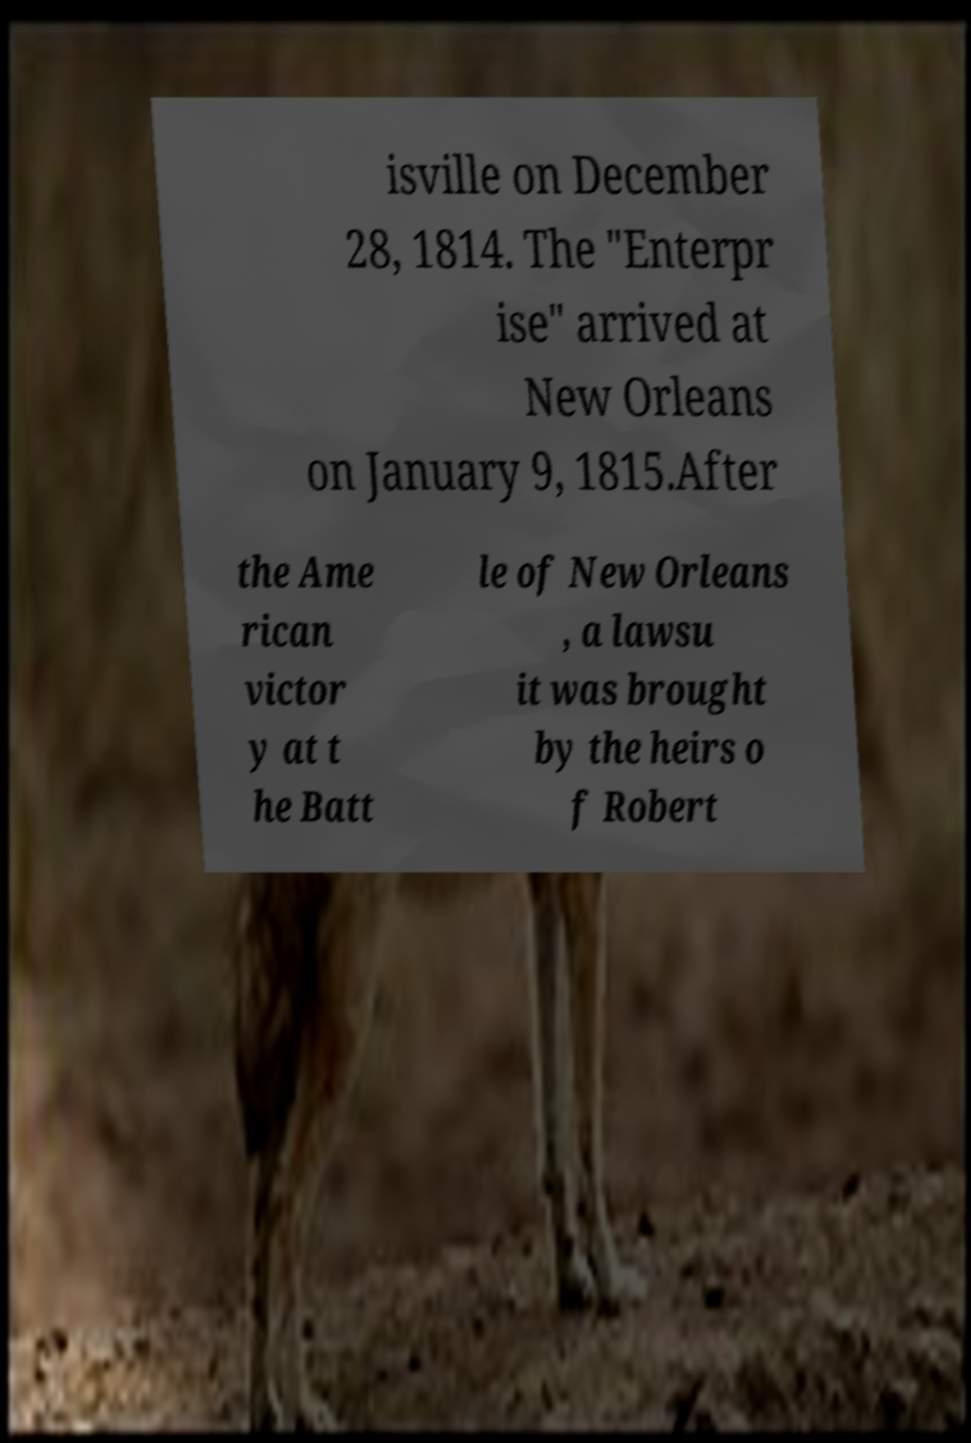I need the written content from this picture converted into text. Can you do that? isville on December 28, 1814. The "Enterpr ise" arrived at New Orleans on January 9, 1815.After the Ame rican victor y at t he Batt le of New Orleans , a lawsu it was brought by the heirs o f Robert 